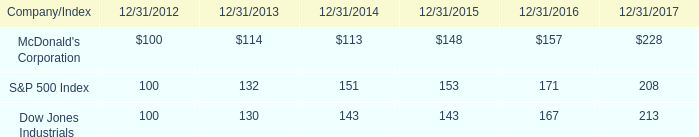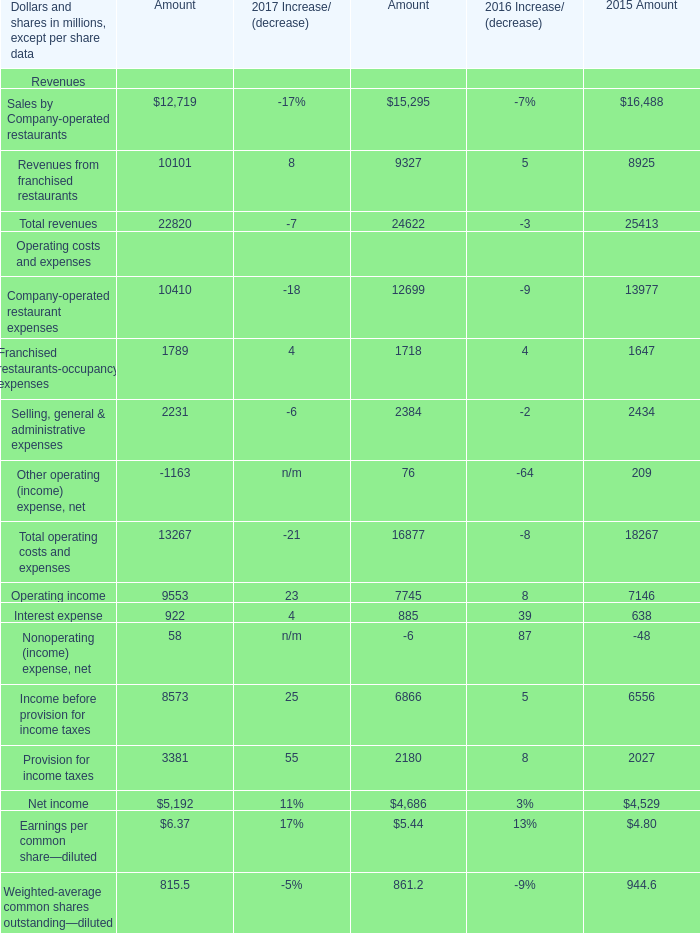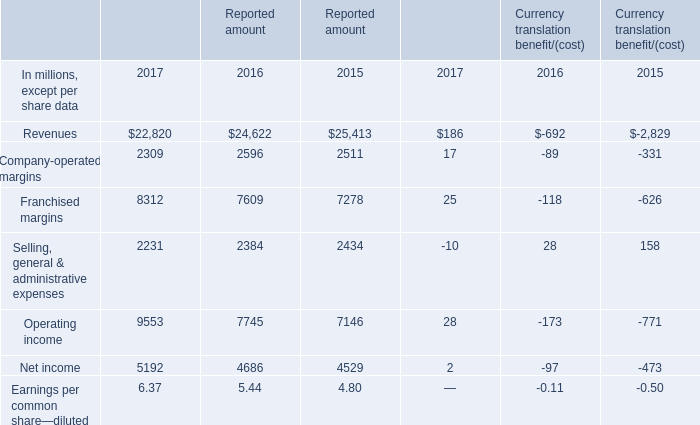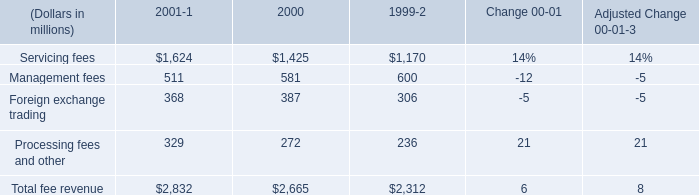What is the growing rate of Interest expense in the year with the most Operating income? 
Computations: ((922 - 885) / 885)
Answer: 0.04181. 